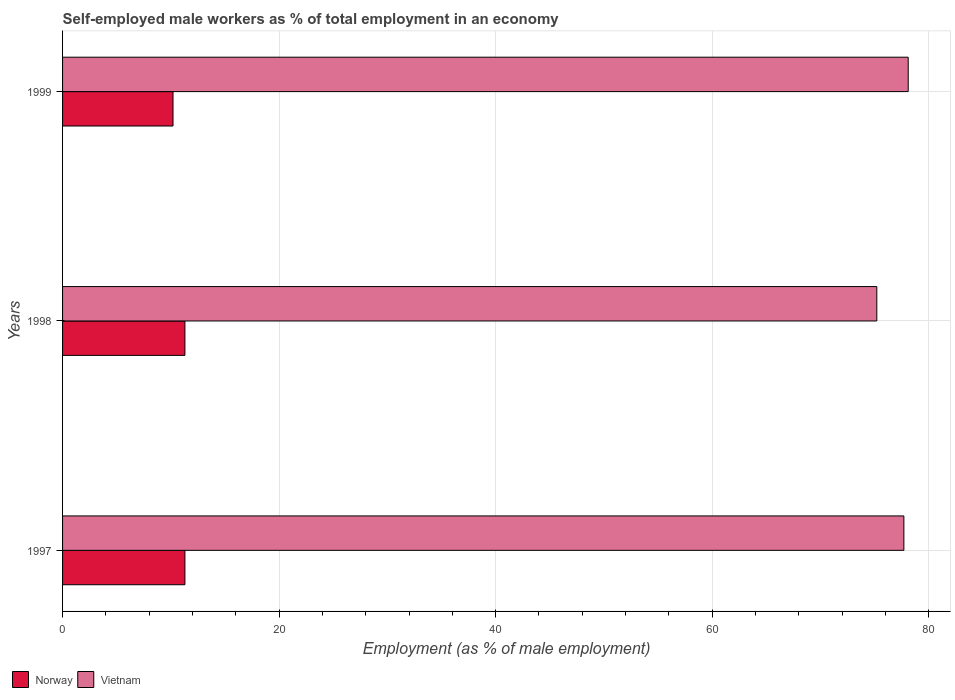How many different coloured bars are there?
Your answer should be very brief. 2. How many bars are there on the 2nd tick from the top?
Make the answer very short. 2. How many bars are there on the 1st tick from the bottom?
Your response must be concise. 2. In how many cases, is the number of bars for a given year not equal to the number of legend labels?
Your answer should be compact. 0. What is the percentage of self-employed male workers in Norway in 1997?
Provide a short and direct response. 11.3. Across all years, what is the maximum percentage of self-employed male workers in Norway?
Provide a succinct answer. 11.3. Across all years, what is the minimum percentage of self-employed male workers in Norway?
Your answer should be compact. 10.2. What is the total percentage of self-employed male workers in Vietnam in the graph?
Provide a short and direct response. 231. What is the difference between the percentage of self-employed male workers in Norway in 1998 and that in 1999?
Your response must be concise. 1.1. What is the difference between the percentage of self-employed male workers in Vietnam in 1997 and the percentage of self-employed male workers in Norway in 1998?
Give a very brief answer. 66.4. What is the average percentage of self-employed male workers in Vietnam per year?
Ensure brevity in your answer.  77. In the year 1997, what is the difference between the percentage of self-employed male workers in Vietnam and percentage of self-employed male workers in Norway?
Provide a succinct answer. 66.4. In how many years, is the percentage of self-employed male workers in Norway greater than 20 %?
Offer a very short reply. 0. What is the ratio of the percentage of self-employed male workers in Norway in 1998 to that in 1999?
Keep it short and to the point. 1.11. Is the difference between the percentage of self-employed male workers in Vietnam in 1997 and 1999 greater than the difference between the percentage of self-employed male workers in Norway in 1997 and 1999?
Ensure brevity in your answer.  No. What is the difference between the highest and the second highest percentage of self-employed male workers in Vietnam?
Make the answer very short. 0.4. What is the difference between the highest and the lowest percentage of self-employed male workers in Norway?
Provide a short and direct response. 1.1. In how many years, is the percentage of self-employed male workers in Vietnam greater than the average percentage of self-employed male workers in Vietnam taken over all years?
Your answer should be very brief. 2. What does the 1st bar from the top in 1999 represents?
Give a very brief answer. Vietnam. What does the 2nd bar from the bottom in 1999 represents?
Your answer should be very brief. Vietnam. How many bars are there?
Your response must be concise. 6. Are all the bars in the graph horizontal?
Offer a terse response. Yes. What is the difference between two consecutive major ticks on the X-axis?
Your answer should be very brief. 20. Where does the legend appear in the graph?
Keep it short and to the point. Bottom left. How many legend labels are there?
Your response must be concise. 2. What is the title of the graph?
Offer a very short reply. Self-employed male workers as % of total employment in an economy. Does "Channel Islands" appear as one of the legend labels in the graph?
Your answer should be compact. No. What is the label or title of the X-axis?
Your answer should be compact. Employment (as % of male employment). What is the label or title of the Y-axis?
Your answer should be compact. Years. What is the Employment (as % of male employment) of Norway in 1997?
Ensure brevity in your answer.  11.3. What is the Employment (as % of male employment) in Vietnam in 1997?
Make the answer very short. 77.7. What is the Employment (as % of male employment) of Norway in 1998?
Provide a succinct answer. 11.3. What is the Employment (as % of male employment) of Vietnam in 1998?
Your response must be concise. 75.2. What is the Employment (as % of male employment) of Norway in 1999?
Make the answer very short. 10.2. What is the Employment (as % of male employment) in Vietnam in 1999?
Make the answer very short. 78.1. Across all years, what is the maximum Employment (as % of male employment) in Norway?
Ensure brevity in your answer.  11.3. Across all years, what is the maximum Employment (as % of male employment) in Vietnam?
Provide a succinct answer. 78.1. Across all years, what is the minimum Employment (as % of male employment) in Norway?
Keep it short and to the point. 10.2. Across all years, what is the minimum Employment (as % of male employment) of Vietnam?
Ensure brevity in your answer.  75.2. What is the total Employment (as % of male employment) of Norway in the graph?
Offer a terse response. 32.8. What is the total Employment (as % of male employment) of Vietnam in the graph?
Your answer should be compact. 231. What is the difference between the Employment (as % of male employment) of Norway in 1997 and that in 1998?
Provide a succinct answer. 0. What is the difference between the Employment (as % of male employment) in Vietnam in 1998 and that in 1999?
Provide a short and direct response. -2.9. What is the difference between the Employment (as % of male employment) in Norway in 1997 and the Employment (as % of male employment) in Vietnam in 1998?
Your answer should be compact. -63.9. What is the difference between the Employment (as % of male employment) in Norway in 1997 and the Employment (as % of male employment) in Vietnam in 1999?
Offer a very short reply. -66.8. What is the difference between the Employment (as % of male employment) of Norway in 1998 and the Employment (as % of male employment) of Vietnam in 1999?
Provide a succinct answer. -66.8. What is the average Employment (as % of male employment) in Norway per year?
Offer a very short reply. 10.93. In the year 1997, what is the difference between the Employment (as % of male employment) of Norway and Employment (as % of male employment) of Vietnam?
Offer a terse response. -66.4. In the year 1998, what is the difference between the Employment (as % of male employment) in Norway and Employment (as % of male employment) in Vietnam?
Offer a terse response. -63.9. In the year 1999, what is the difference between the Employment (as % of male employment) in Norway and Employment (as % of male employment) in Vietnam?
Your answer should be very brief. -67.9. What is the ratio of the Employment (as % of male employment) of Vietnam in 1997 to that in 1998?
Offer a terse response. 1.03. What is the ratio of the Employment (as % of male employment) of Norway in 1997 to that in 1999?
Give a very brief answer. 1.11. What is the ratio of the Employment (as % of male employment) of Vietnam in 1997 to that in 1999?
Ensure brevity in your answer.  0.99. What is the ratio of the Employment (as % of male employment) of Norway in 1998 to that in 1999?
Give a very brief answer. 1.11. What is the ratio of the Employment (as % of male employment) of Vietnam in 1998 to that in 1999?
Offer a terse response. 0.96. What is the difference between the highest and the lowest Employment (as % of male employment) of Norway?
Ensure brevity in your answer.  1.1. What is the difference between the highest and the lowest Employment (as % of male employment) in Vietnam?
Provide a short and direct response. 2.9. 